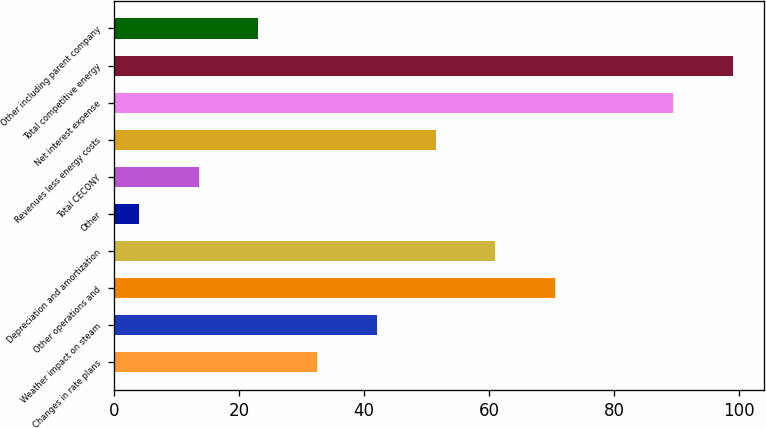<chart> <loc_0><loc_0><loc_500><loc_500><bar_chart><fcel>Changes in rate plans<fcel>Weather impact on steam<fcel>Other operations and<fcel>Depreciation and amortization<fcel>Other<fcel>Total CECONY<fcel>Revenues less energy costs<fcel>Net interest expense<fcel>Total competitive energy<fcel>Other including parent company<nl><fcel>32.5<fcel>42<fcel>70.5<fcel>61<fcel>4<fcel>13.5<fcel>51.5<fcel>89.5<fcel>99<fcel>23<nl></chart> 